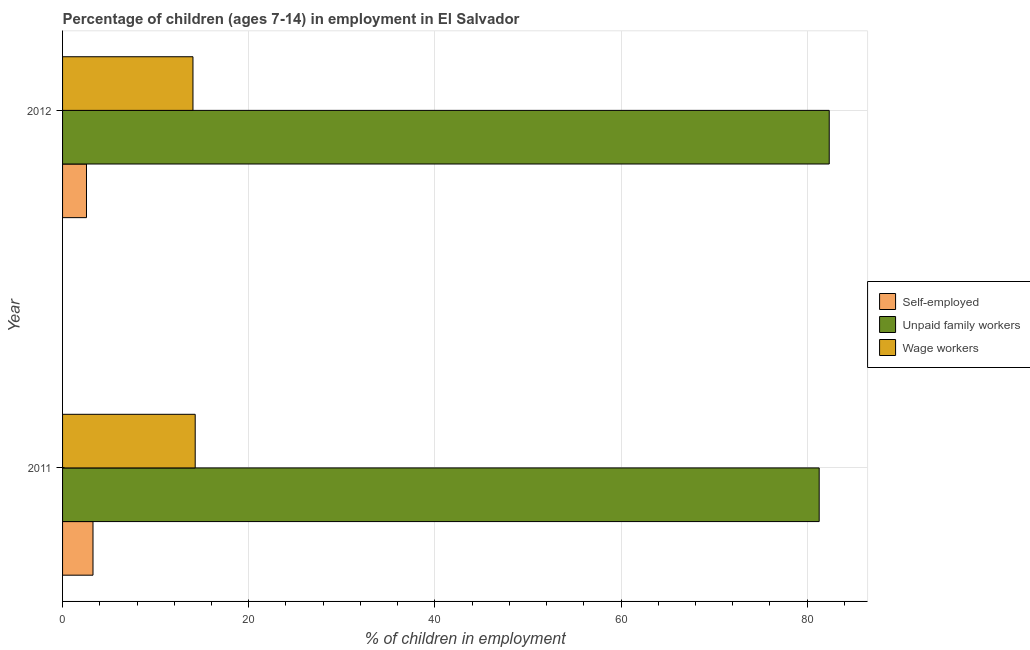How many groups of bars are there?
Your response must be concise. 2. Are the number of bars per tick equal to the number of legend labels?
Make the answer very short. Yes. How many bars are there on the 1st tick from the top?
Offer a very short reply. 3. In how many cases, is the number of bars for a given year not equal to the number of legend labels?
Provide a short and direct response. 0. What is the percentage of self employed children in 2011?
Ensure brevity in your answer.  3.27. Across all years, what is the maximum percentage of self employed children?
Provide a short and direct response. 3.27. Across all years, what is the minimum percentage of children employed as unpaid family workers?
Your answer should be compact. 81.29. In which year was the percentage of self employed children maximum?
Give a very brief answer. 2011. What is the total percentage of children employed as wage workers in the graph?
Keep it short and to the point. 28.26. What is the difference between the percentage of children employed as unpaid family workers in 2011 and that in 2012?
Your answer should be very brief. -1.08. What is the difference between the percentage of children employed as unpaid family workers in 2011 and the percentage of children employed as wage workers in 2012?
Ensure brevity in your answer.  67.28. What is the average percentage of children employed as unpaid family workers per year?
Your answer should be very brief. 81.83. In the year 2011, what is the difference between the percentage of children employed as unpaid family workers and percentage of children employed as wage workers?
Your response must be concise. 67.04. In how many years, is the percentage of self employed children greater than 56 %?
Your answer should be compact. 0. Is the difference between the percentage of children employed as wage workers in 2011 and 2012 greater than the difference between the percentage of self employed children in 2011 and 2012?
Keep it short and to the point. No. In how many years, is the percentage of children employed as wage workers greater than the average percentage of children employed as wage workers taken over all years?
Keep it short and to the point. 1. What does the 2nd bar from the top in 2011 represents?
Your answer should be very brief. Unpaid family workers. What does the 1st bar from the bottom in 2011 represents?
Your answer should be very brief. Self-employed. Is it the case that in every year, the sum of the percentage of self employed children and percentage of children employed as unpaid family workers is greater than the percentage of children employed as wage workers?
Offer a very short reply. Yes. How many bars are there?
Your answer should be very brief. 6. Are all the bars in the graph horizontal?
Your response must be concise. Yes. How many years are there in the graph?
Make the answer very short. 2. Does the graph contain grids?
Your response must be concise. Yes. How are the legend labels stacked?
Your response must be concise. Vertical. What is the title of the graph?
Provide a succinct answer. Percentage of children (ages 7-14) in employment in El Salvador. What is the label or title of the X-axis?
Your answer should be very brief. % of children in employment. What is the label or title of the Y-axis?
Offer a very short reply. Year. What is the % of children in employment in Self-employed in 2011?
Give a very brief answer. 3.27. What is the % of children in employment of Unpaid family workers in 2011?
Your answer should be compact. 81.29. What is the % of children in employment in Wage workers in 2011?
Give a very brief answer. 14.25. What is the % of children in employment of Self-employed in 2012?
Your answer should be compact. 2.57. What is the % of children in employment in Unpaid family workers in 2012?
Your answer should be compact. 82.37. What is the % of children in employment in Wage workers in 2012?
Provide a short and direct response. 14.01. Across all years, what is the maximum % of children in employment in Self-employed?
Give a very brief answer. 3.27. Across all years, what is the maximum % of children in employment of Unpaid family workers?
Ensure brevity in your answer.  82.37. Across all years, what is the maximum % of children in employment in Wage workers?
Give a very brief answer. 14.25. Across all years, what is the minimum % of children in employment in Self-employed?
Keep it short and to the point. 2.57. Across all years, what is the minimum % of children in employment in Unpaid family workers?
Your answer should be compact. 81.29. Across all years, what is the minimum % of children in employment in Wage workers?
Give a very brief answer. 14.01. What is the total % of children in employment of Self-employed in the graph?
Provide a short and direct response. 5.84. What is the total % of children in employment in Unpaid family workers in the graph?
Your response must be concise. 163.66. What is the total % of children in employment of Wage workers in the graph?
Ensure brevity in your answer.  28.26. What is the difference between the % of children in employment of Unpaid family workers in 2011 and that in 2012?
Give a very brief answer. -1.08. What is the difference between the % of children in employment of Wage workers in 2011 and that in 2012?
Offer a terse response. 0.24. What is the difference between the % of children in employment in Self-employed in 2011 and the % of children in employment in Unpaid family workers in 2012?
Give a very brief answer. -79.1. What is the difference between the % of children in employment of Self-employed in 2011 and the % of children in employment of Wage workers in 2012?
Make the answer very short. -10.74. What is the difference between the % of children in employment of Unpaid family workers in 2011 and the % of children in employment of Wage workers in 2012?
Your answer should be very brief. 67.28. What is the average % of children in employment in Self-employed per year?
Offer a very short reply. 2.92. What is the average % of children in employment in Unpaid family workers per year?
Your response must be concise. 81.83. What is the average % of children in employment in Wage workers per year?
Your answer should be very brief. 14.13. In the year 2011, what is the difference between the % of children in employment in Self-employed and % of children in employment in Unpaid family workers?
Give a very brief answer. -78.02. In the year 2011, what is the difference between the % of children in employment of Self-employed and % of children in employment of Wage workers?
Make the answer very short. -10.98. In the year 2011, what is the difference between the % of children in employment in Unpaid family workers and % of children in employment in Wage workers?
Provide a succinct answer. 67.04. In the year 2012, what is the difference between the % of children in employment in Self-employed and % of children in employment in Unpaid family workers?
Provide a succinct answer. -79.8. In the year 2012, what is the difference between the % of children in employment of Self-employed and % of children in employment of Wage workers?
Offer a terse response. -11.44. In the year 2012, what is the difference between the % of children in employment of Unpaid family workers and % of children in employment of Wage workers?
Ensure brevity in your answer.  68.36. What is the ratio of the % of children in employment of Self-employed in 2011 to that in 2012?
Provide a succinct answer. 1.27. What is the ratio of the % of children in employment in Unpaid family workers in 2011 to that in 2012?
Your answer should be very brief. 0.99. What is the ratio of the % of children in employment of Wage workers in 2011 to that in 2012?
Ensure brevity in your answer.  1.02. What is the difference between the highest and the second highest % of children in employment of Self-employed?
Make the answer very short. 0.7. What is the difference between the highest and the second highest % of children in employment in Unpaid family workers?
Offer a very short reply. 1.08. What is the difference between the highest and the second highest % of children in employment of Wage workers?
Your response must be concise. 0.24. What is the difference between the highest and the lowest % of children in employment in Self-employed?
Give a very brief answer. 0.7. What is the difference between the highest and the lowest % of children in employment in Unpaid family workers?
Your answer should be very brief. 1.08. What is the difference between the highest and the lowest % of children in employment in Wage workers?
Make the answer very short. 0.24. 